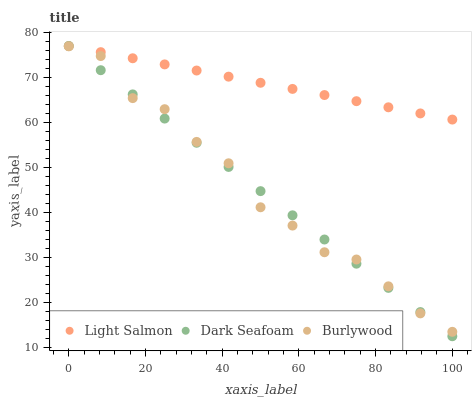Does Burlywood have the minimum area under the curve?
Answer yes or no. Yes. Does Light Salmon have the maximum area under the curve?
Answer yes or no. Yes. Does Dark Seafoam have the minimum area under the curve?
Answer yes or no. No. Does Dark Seafoam have the maximum area under the curve?
Answer yes or no. No. Is Dark Seafoam the smoothest?
Answer yes or no. Yes. Is Burlywood the roughest?
Answer yes or no. Yes. Is Light Salmon the smoothest?
Answer yes or no. No. Is Light Salmon the roughest?
Answer yes or no. No. Does Dark Seafoam have the lowest value?
Answer yes or no. Yes. Does Light Salmon have the lowest value?
Answer yes or no. No. Does Dark Seafoam have the highest value?
Answer yes or no. Yes. Is Burlywood less than Light Salmon?
Answer yes or no. Yes. Is Light Salmon greater than Burlywood?
Answer yes or no. Yes. Does Dark Seafoam intersect Light Salmon?
Answer yes or no. Yes. Is Dark Seafoam less than Light Salmon?
Answer yes or no. No. Is Dark Seafoam greater than Light Salmon?
Answer yes or no. No. Does Burlywood intersect Light Salmon?
Answer yes or no. No. 